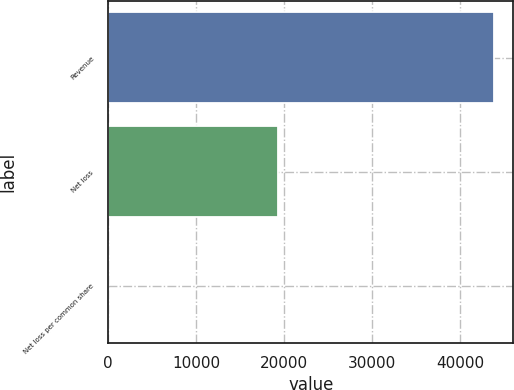Convert chart to OTSL. <chart><loc_0><loc_0><loc_500><loc_500><bar_chart><fcel>Revenue<fcel>Net loss<fcel>Net loss per common share<nl><fcel>43836<fcel>19303<fcel>0.74<nl></chart> 